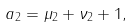Convert formula to latex. <formula><loc_0><loc_0><loc_500><loc_500>a _ { 2 } = \mu _ { 2 } + \nu _ { 2 } + 1 ,</formula> 